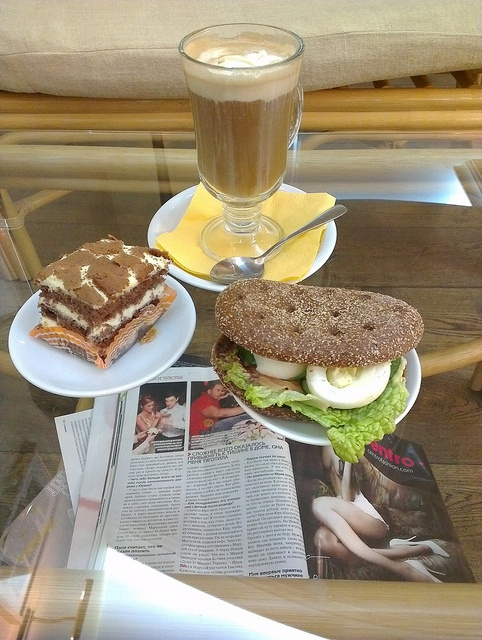Describe the objects in this image and their specific colors. I can see dining table in tan, darkgray, gray, and lightgray tones, book in tan, darkgray, gray, lightgray, and black tones, couch in tan tones, sandwich in tan, gray, olive, and ivory tones, and cup in tan and olive tones in this image. 